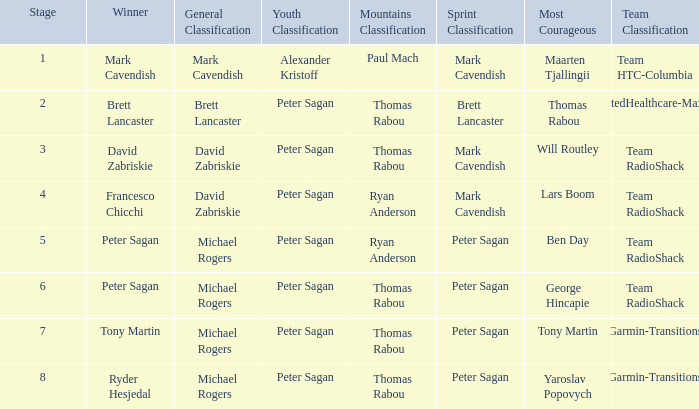Can you give me this table as a dict? {'header': ['Stage', 'Winner', 'General Classification', 'Youth Classification', 'Mountains Classification', 'Sprint Classification', 'Most Courageous', 'Team Classification'], 'rows': [['1', 'Mark Cavendish', 'Mark Cavendish', 'Alexander Kristoff', 'Paul Mach', 'Mark Cavendish', 'Maarten Tjallingii', 'Team HTC-Columbia'], ['2', 'Brett Lancaster', 'Brett Lancaster', 'Peter Sagan', 'Thomas Rabou', 'Brett Lancaster', 'Thomas Rabou', 'UnitedHealthcare-Maxxis'], ['3', 'David Zabriskie', 'David Zabriskie', 'Peter Sagan', 'Thomas Rabou', 'Mark Cavendish', 'Will Routley', 'Team RadioShack'], ['4', 'Francesco Chicchi', 'David Zabriskie', 'Peter Sagan', 'Ryan Anderson', 'Mark Cavendish', 'Lars Boom', 'Team RadioShack'], ['5', 'Peter Sagan', 'Michael Rogers', 'Peter Sagan', 'Ryan Anderson', 'Peter Sagan', 'Ben Day', 'Team RadioShack'], ['6', 'Peter Sagan', 'Michael Rogers', 'Peter Sagan', 'Thomas Rabou', 'Peter Sagan', 'George Hincapie', 'Team RadioShack'], ['7', 'Tony Martin', 'Michael Rogers', 'Peter Sagan', 'Thomas Rabou', 'Peter Sagan', 'Tony Martin', 'Garmin-Transitions'], ['8', 'Ryder Hesjedal', 'Michael Rogers', 'Peter Sagan', 'Thomas Rabou', 'Peter Sagan', 'Yaroslav Popovych', 'Garmin-Transitions']]} When Ryan Anderson won the mountains classification, and Michael Rogers won the general classification, who won the sprint classification? Peter Sagan. 